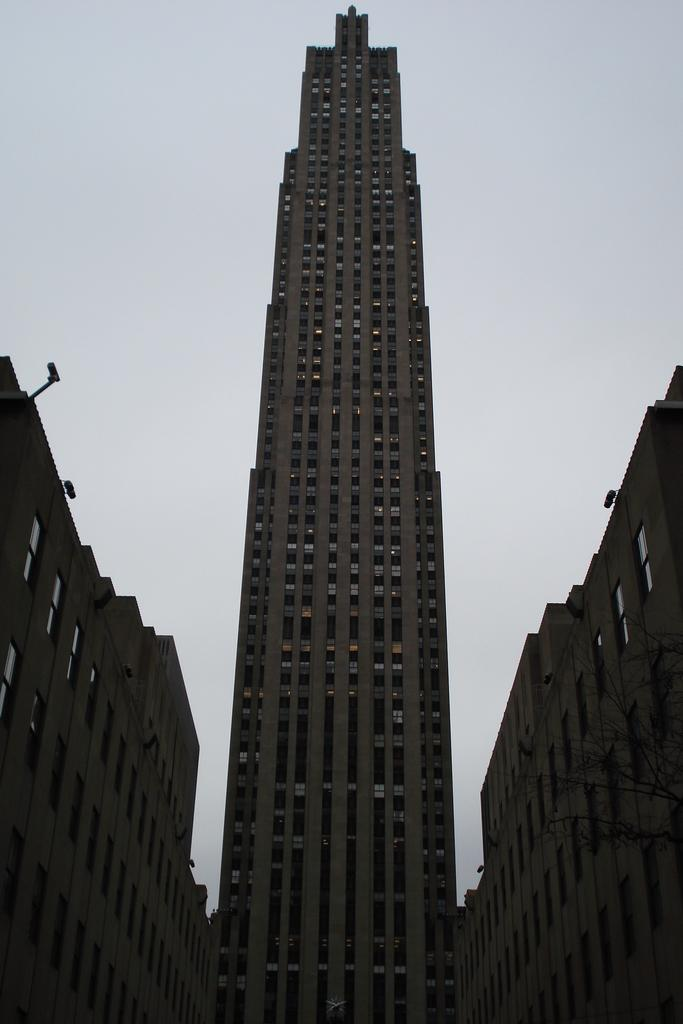What structures can be seen in the image? There are buildings in the image. What feature do the buildings have in common? The buildings have windows. What type of beetle can be seen crawling on the buildings in the image? There are no beetles present in the image; it only features buildings with windows. 